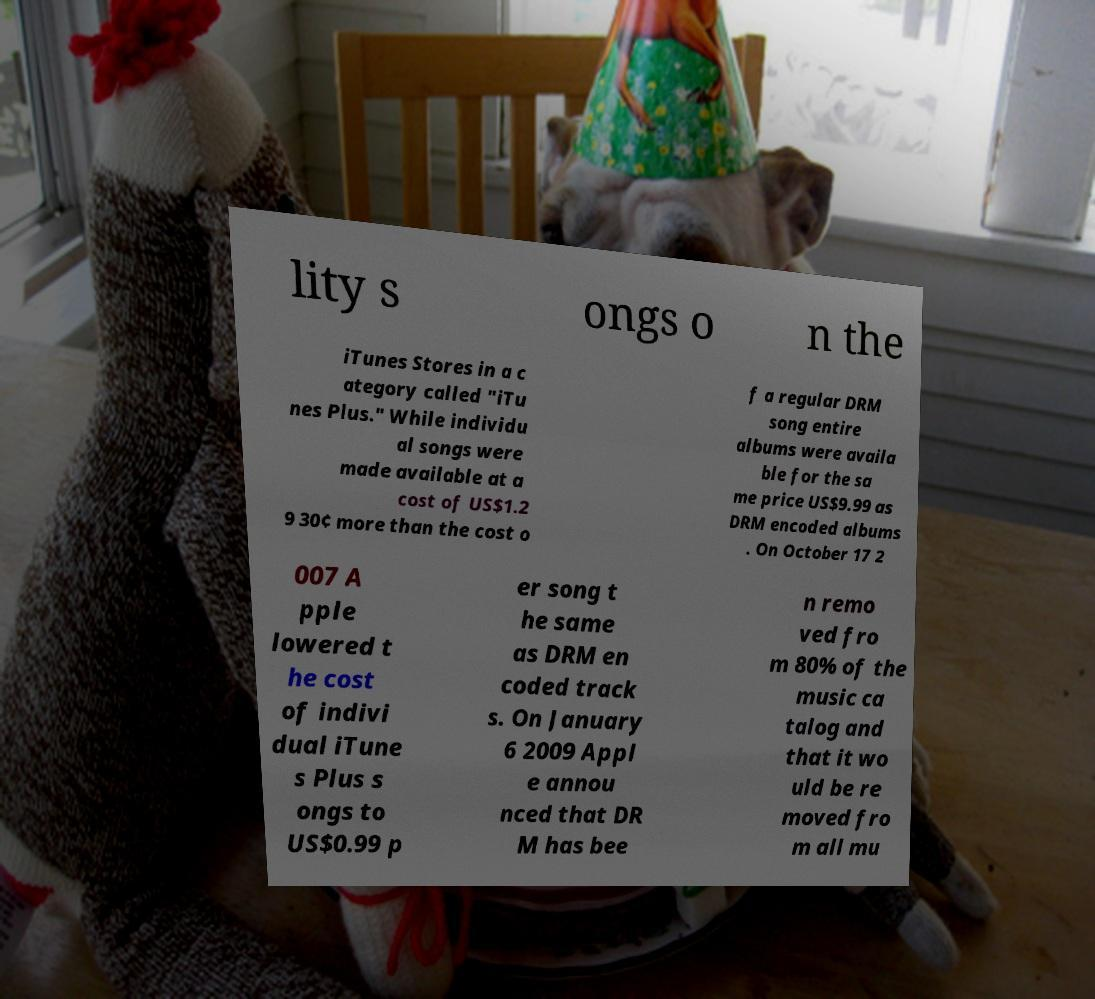Can you accurately transcribe the text from the provided image for me? lity s ongs o n the iTunes Stores in a c ategory called "iTu nes Plus." While individu al songs were made available at a cost of US$1.2 9 30¢ more than the cost o f a regular DRM song entire albums were availa ble for the sa me price US$9.99 as DRM encoded albums . On October 17 2 007 A pple lowered t he cost of indivi dual iTune s Plus s ongs to US$0.99 p er song t he same as DRM en coded track s. On January 6 2009 Appl e annou nced that DR M has bee n remo ved fro m 80% of the music ca talog and that it wo uld be re moved fro m all mu 